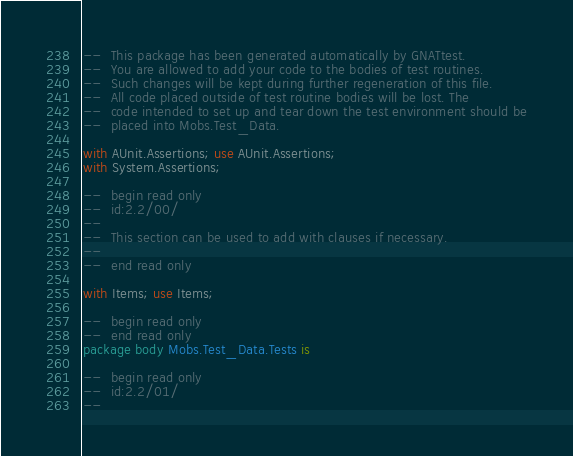<code> <loc_0><loc_0><loc_500><loc_500><_Ada_>--  This package has been generated automatically by GNATtest.
--  You are allowed to add your code to the bodies of test routines.
--  Such changes will be kept during further regeneration of this file.
--  All code placed outside of test routine bodies will be lost. The
--  code intended to set up and tear down the test environment should be
--  placed into Mobs.Test_Data.

with AUnit.Assertions; use AUnit.Assertions;
with System.Assertions;

--  begin read only
--  id:2.2/00/
--
--  This section can be used to add with clauses if necessary.
--
--  end read only

with Items; use Items;

--  begin read only
--  end read only
package body Mobs.Test_Data.Tests is

--  begin read only
--  id:2.2/01/
--</code> 